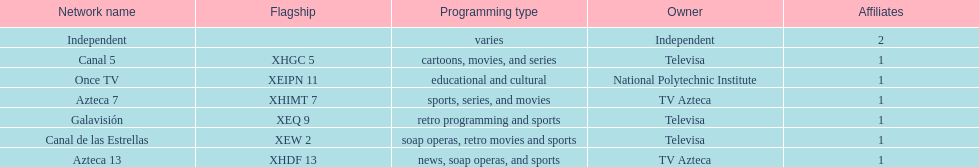What is the average number of affiliates that a given network will have? 1. 